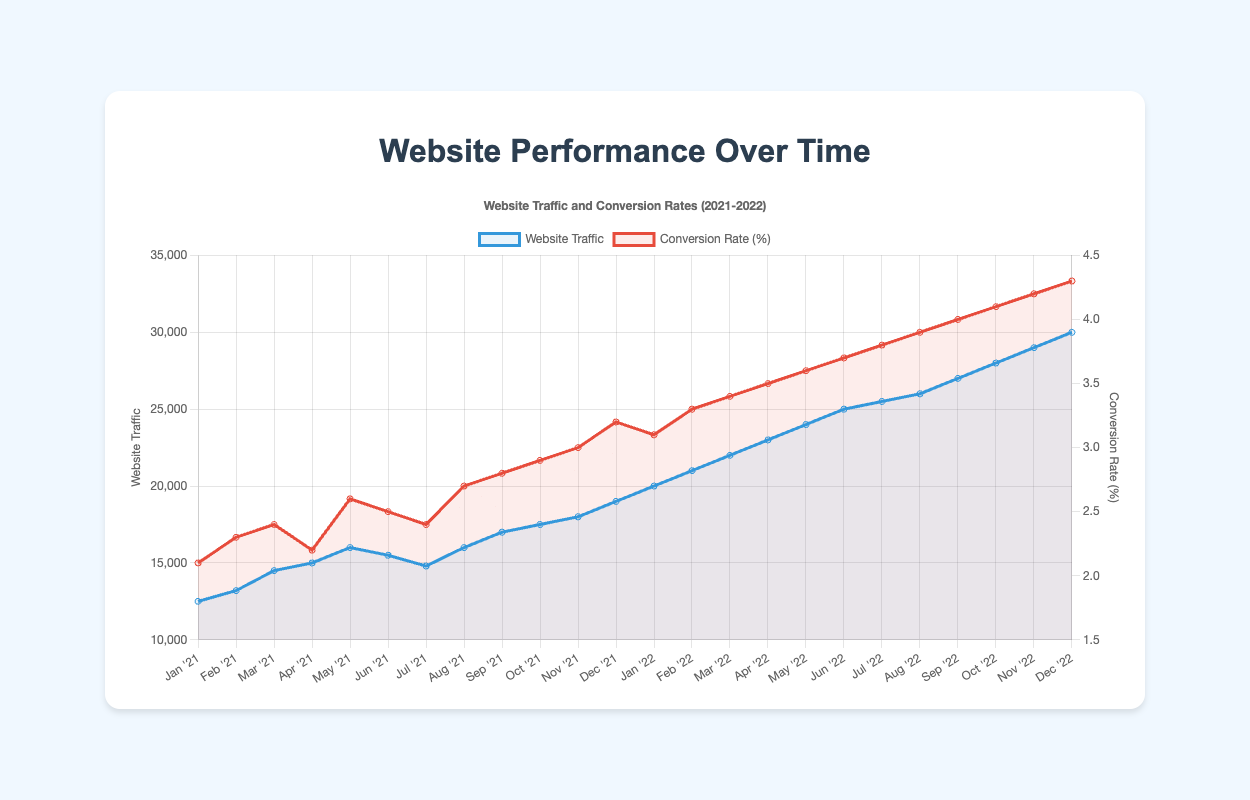What's the highest website traffic recorded and in which month? From the figure, the highest website traffic is at the end of the year 2022. This peak is associated with the month of December 2022, where the traffic hits 30,000.
Answer: 30,000, December 2022 Compare the conversion rates of January 2021 and January 2022. Which month had a higher conversion rate and by how much? The conversion rate in January 2021 is 2.1%, and in January 2022, it is 3.1%. The difference is calculated as 3.1% - 2.1% = 1%.
Answer: January 2022 by 1% How did the website traffic trend change from May 2021 to June 2021? In May 2021, the traffic was 16,000, and in June 2021, it decreased to 15,500. This indicates a slight drop.
Answer: Decreased What was the percentage increase in website traffic from January 2021 to December 2022? The traffic in January 2021 is 12,500, and in December 2022, it is 30,000. The percentage increase is calculated as ((30,000 - 12,500) / 12,500) * 100 = 140%.
Answer: 140% Which month shows the highest conversion rate, and what is it? The highest conversion rate is in December 2022, recorded at 4.3%.
Answer: December 2022, 4.3% How many months in 2022 had a conversion rate of 4.0% or higher? From the figure, starting from September 2022 (4.0%), October 2022 (4.1%), November 2022 (4.2%), and December 2022 (4.3%) had a conversion rate of 4.0% or higher. Summing these, we get a total of 4 months.
Answer: 4 months Between which two consecutive months did the website traffic show the highest increase? The highest rise in website traffic is observed between January 2021 (12,500) and February 2021 (13,200), where the increase is 13,200 - 12,500 = 700. By comparing all other consecutive month changes, it's verified as the maximum increase.
Answer: January - February 2021 